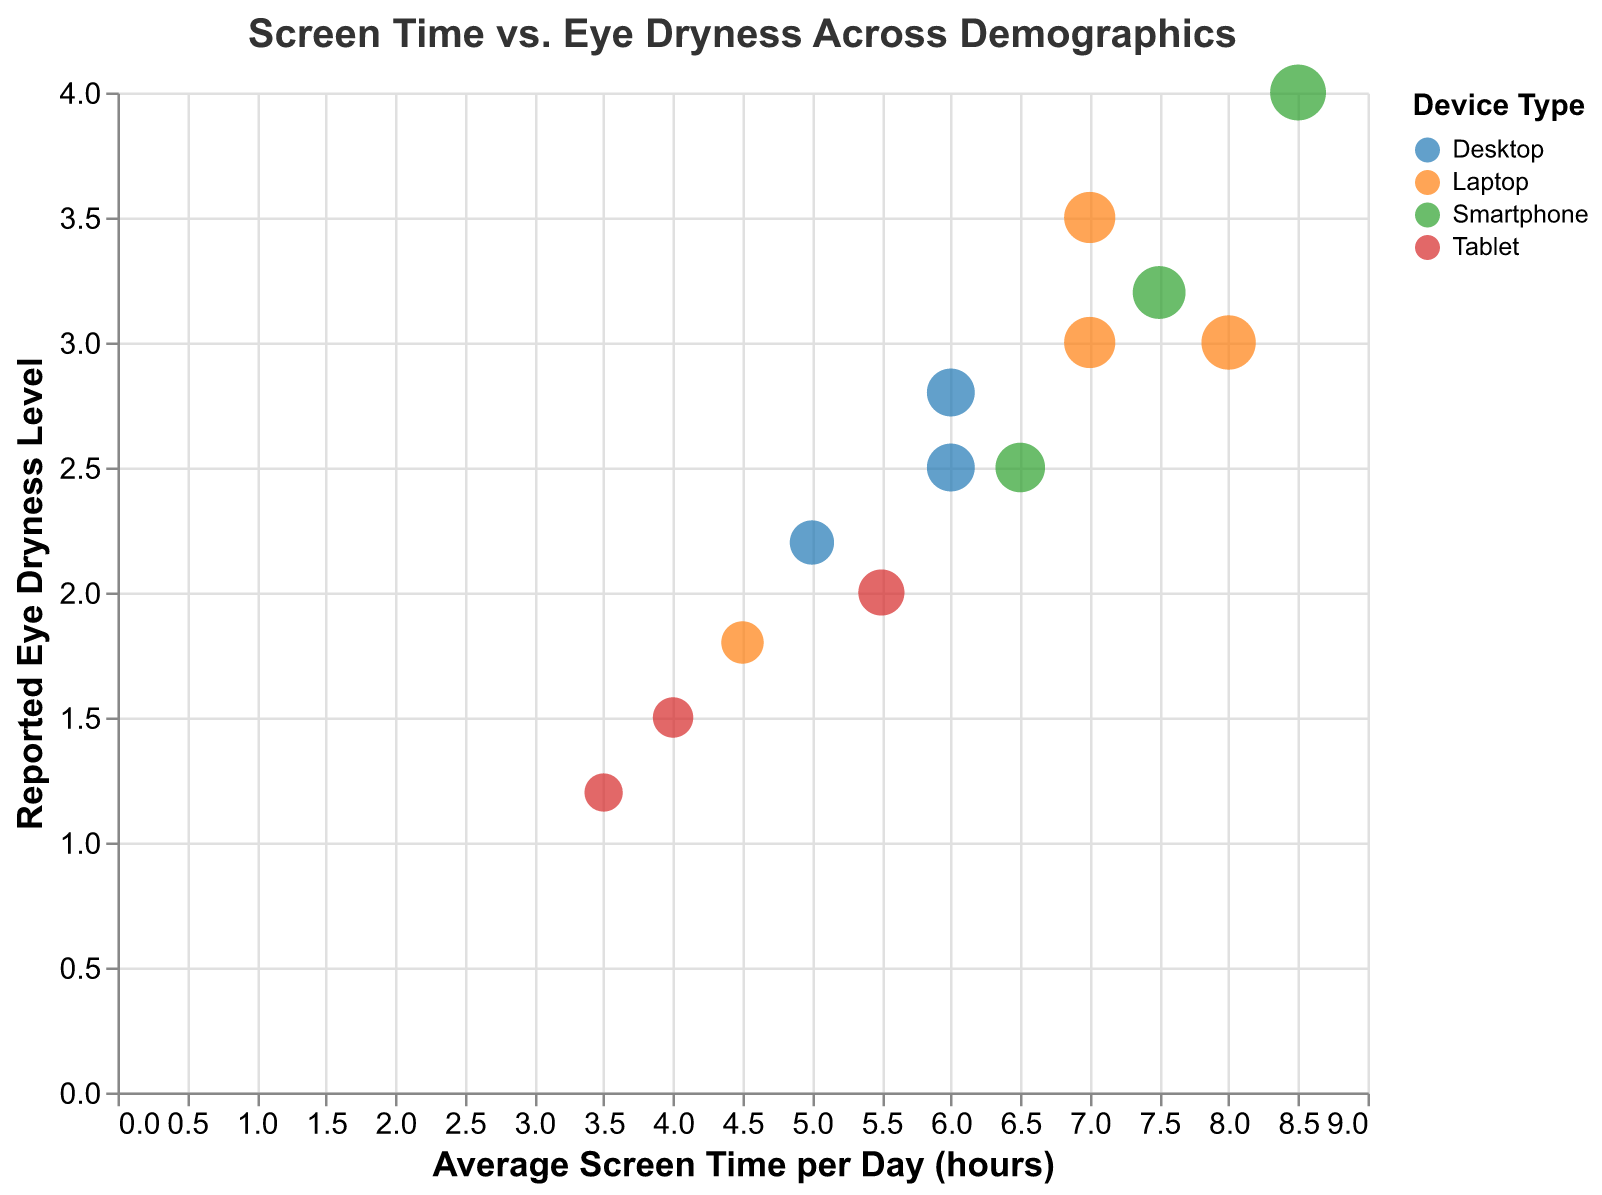What is the title of the figure? The title is displayed at the top of the figure and reads "Screen Time vs. Eye Dryness Across Demographics".
Answer: Screen Time vs. Eye Dryness Across Demographics Which axis represents the average screen time per day? The horizontal axis (x-axis) represents the average screen time per day, as indicated by the axis title "Average Screen Time per Day (hours)".
Answer: The horizontal axis (x-axis) Which age group has the highest reported eye dryness level for tablet usage? To find this, look at the bubbles colored according to device type for tablets and check the labels and positions on the y-axis. The age group 25-34 using a tablet reports a dryness level of 2.0, 45-54 reports 1.5, and 55-64 reports 1.2.
Answer: 25-34 How many data points are there for the age group 45-54? Count the number of distinct bubbles associated with the age group 45-54. There are three bubbles for this age group.
Answer: 3 For the age group 18-24, which device type corresponds to the lower reported eye dryness level? Compare the y-axis positions of the bubbles for the age group 18-24. There is one bubble for laptops and one for smartphones. The lower value on the y-axis (2.5) corresponds to smartphones.
Answer: Smartphone Which device type shows the highest reported eye dryness level overall? Identify the bubble with the highest y-axis position across all device types. The highest reported dryness level of 4.0 is for a smartphone (age group 25-34).
Answer: Smartphone What is the average screen time (hours) for the age group 55-64 with reported eye dryness level of 1.8? Locate the bubble for age group 55-64 with a y-axis value of 1.8. The x-axis value corresponding to this is 4.5 hours.
Answer: 4.5 hours Compare the relationship between screen time and eye dryness level for laptops and desktops across all age groups. This involves comparing the trends and positions of bubbles colored for laptops and desktops. Laptops generally show higher screen times and eye dryness levels compared to desktops.
Answer: Laptops generally higher What is the reported eye dryness level for the 45-54 age group with the highest screen time per day? For the 45-54 age group, find the bubble with the highest x-axis value. It corresponds to a screen time of 7 hours and a dryness level of 3.0.
Answer: 3.0 If the goal is to reduce eye dryness, which age group and device type combination appears to have the most balanced screen time and dryness level (lower-mid values)? Look for a bubble with mid-range values for screen time and lower dryness levels, balancing the position on both axes. The age group 55-64 with a laptop (screen time 4.5 hours and eye dryness level 1.8) appears balanced.
Answer: 55-64 with a laptop 